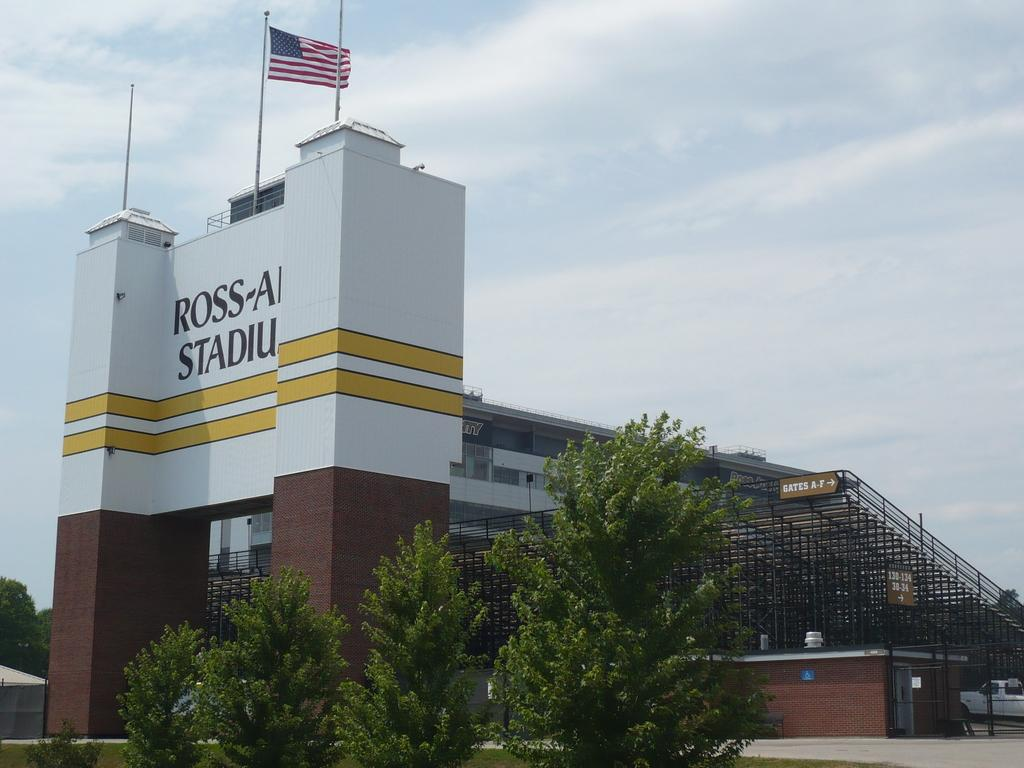<image>
Give a short and clear explanation of the subsequent image. the outside of Ross Stadium with yellow stripes and American flag 